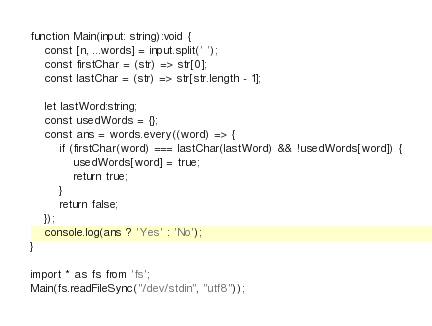<code> <loc_0><loc_0><loc_500><loc_500><_TypeScript_>function Main(input: string):void {
    const [n, ...words] = input.split(' ');
    const firstChar = (str) => str[0];
    const lastChar = (str) => str[str.length - 1];

    let lastWord:string;
    const usedWords = {};
    const ans = words.every((word) => {
        if (firstChar(word) === lastChar(lastWord) && !usedWords[word]) {
            usedWords[word] = true;
            return true;
        }
        return false;
    });
    console.log(ans ? 'Yes' : 'No');
}

import * as fs from 'fs';
Main(fs.readFileSync("/dev/stdin", "utf8"));
</code> 